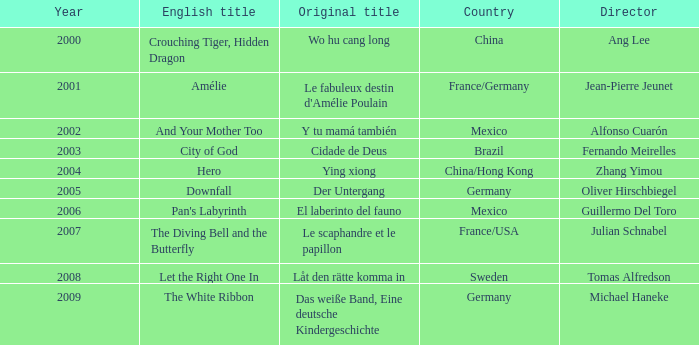Name the title of jean-pierre jeunet Amélie. 